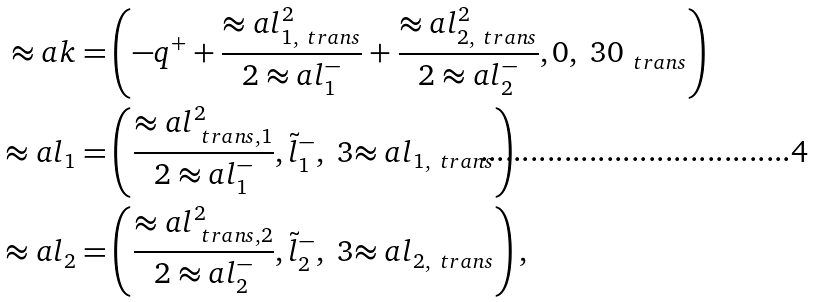<formula> <loc_0><loc_0><loc_500><loc_500>\approx a { k } = & \left ( - q ^ { + } + \frac { \approx a { l } _ { 1 , \ t r a n s } ^ { 2 } } { 2 \approx a { l } ^ { - } _ { 1 } } + \frac { \approx a { l } _ { 2 , \ t r a n s } ^ { 2 } } { 2 \approx a { l } ^ { - } _ { 2 } } , 0 , \ 3 { 0 } _ { \ t r a n s } \right ) \\ \approx a { l } _ { 1 } = & \left ( \frac { \approx a { l } _ { \ t r a n s , 1 } ^ { 2 } } { 2 \approx a { l } ^ { - } _ { 1 } } , \tilde { l } ^ { - } _ { 1 } , \ 3 { \approx a { l } } _ { 1 , \ t r a n s } \right ) \\ \approx a { l } _ { 2 } = & \left ( \frac { \approx a { l } _ { \ t r a n s , 2 } ^ { 2 } } { 2 \approx a { l } ^ { - } _ { 2 } } , \tilde { l } ^ { - } _ { 2 } , \ 3 { \approx a { l } } _ { 2 , \ t r a n s } \right ) ,</formula> 